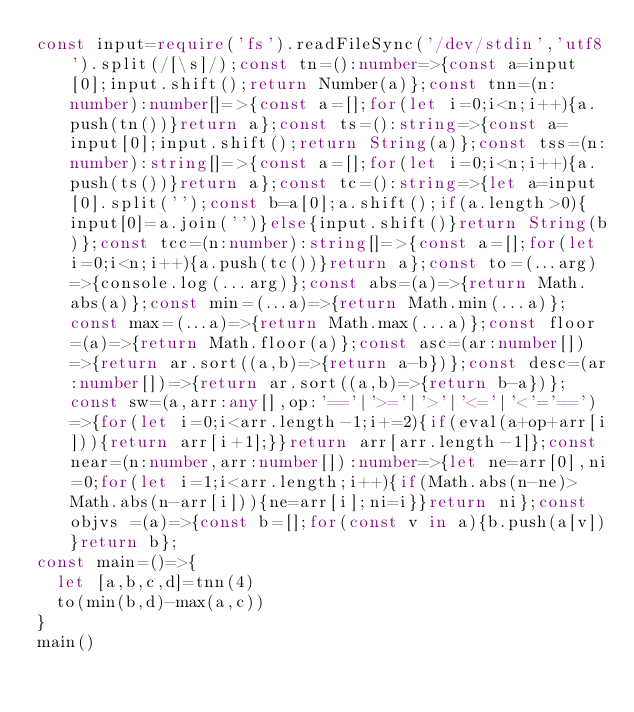Convert code to text. <code><loc_0><loc_0><loc_500><loc_500><_TypeScript_>const input=require('fs').readFileSync('/dev/stdin','utf8').split(/[\s]/);const tn=():number=>{const a=input[0];input.shift();return Number(a)};const tnn=(n:number):number[]=>{const a=[];for(let i=0;i<n;i++){a.push(tn())}return a};const ts=():string=>{const a=input[0];input.shift();return String(a)};const tss=(n:number):string[]=>{const a=[];for(let i=0;i<n;i++){a.push(ts())}return a};const tc=():string=>{let a=input[0].split('');const b=a[0];a.shift();if(a.length>0){input[0]=a.join('')}else{input.shift()}return String(b)};const tcc=(n:number):string[]=>{const a=[];for(let i=0;i<n;i++){a.push(tc())}return a};const to=(...arg)=>{console.log(...arg)};const abs=(a)=>{return Math.abs(a)};const min=(...a)=>{return Math.min(...a)};const max=(...a)=>{return Math.max(...a)};const floor=(a)=>{return Math.floor(a)};const asc=(ar:number[])=>{return ar.sort((a,b)=>{return a-b})};const desc=(ar:number[])=>{return ar.sort((a,b)=>{return b-a})};const sw=(a,arr:any[],op:'=='|'>='|'>'|'<='|'<'='==')=>{for(let i=0;i<arr.length-1;i+=2){if(eval(a+op+arr[i])){return arr[i+1];}}return arr[arr.length-1]};const near=(n:number,arr:number[]):number=>{let ne=arr[0],ni=0;for(let i=1;i<arr.length;i++){if(Math.abs(n-ne)>Math.abs(n-arr[i])){ne=arr[i];ni=i}}return ni};const objvs =(a)=>{const b=[];for(const v in a){b.push(a[v])}return b};
const main=()=>{
  let [a,b,c,d]=tnn(4)
  to(min(b,d)-max(a,c))
}
main()
</code> 